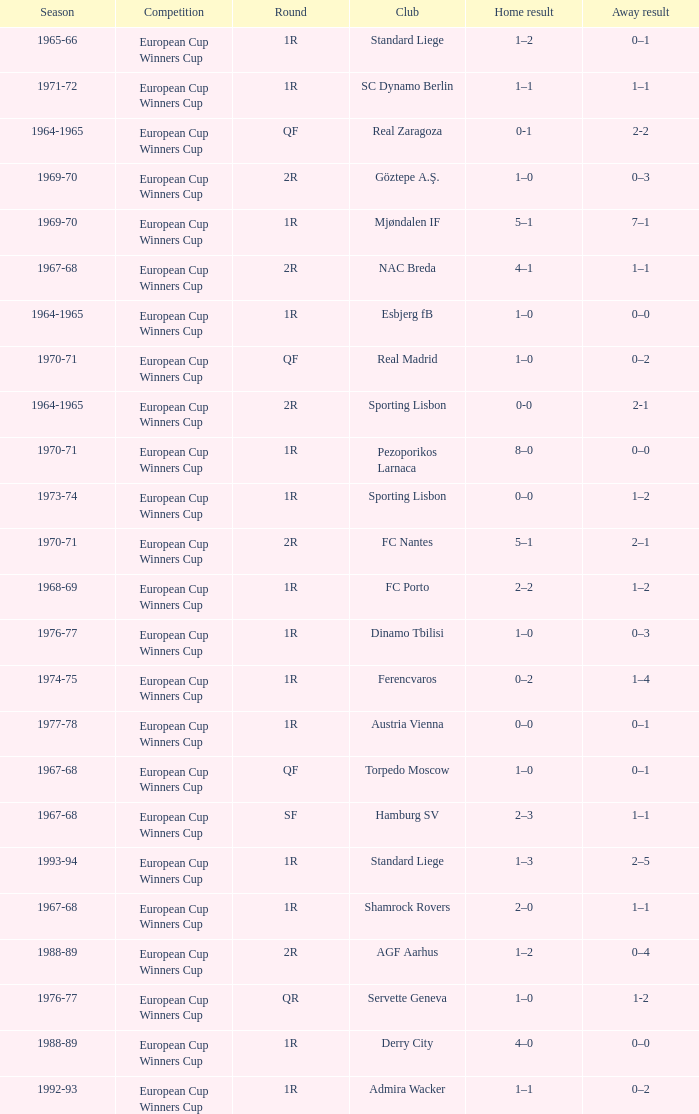Away result of 1-2 has what season? 1976-77. 